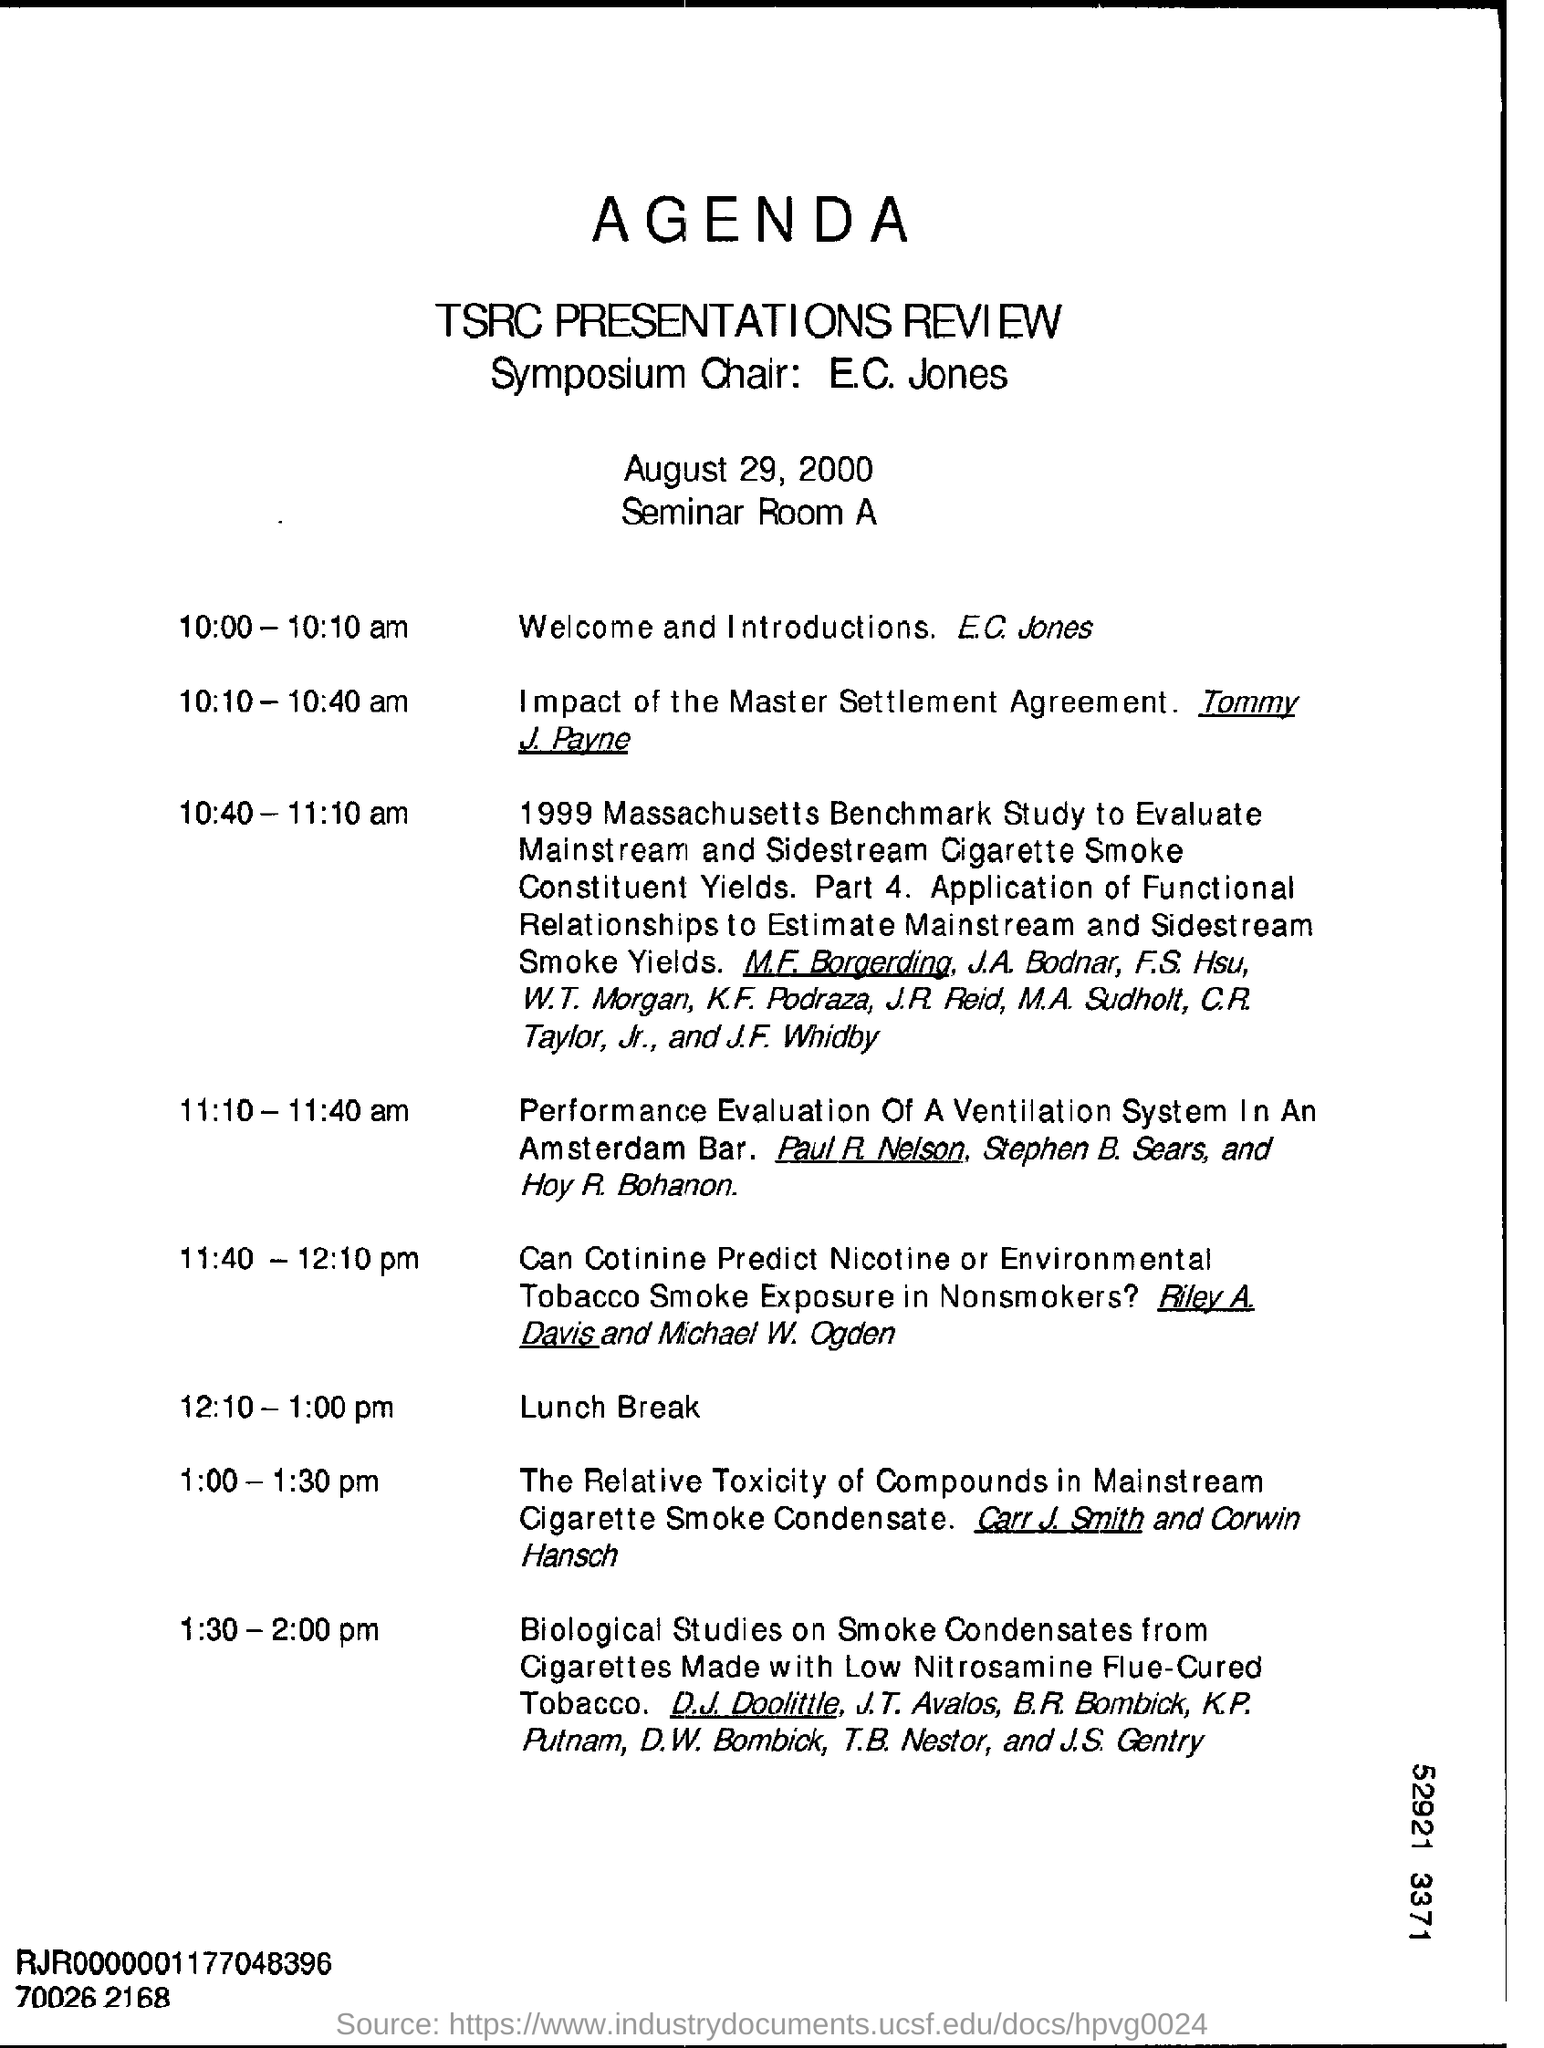Mention a couple of crucial points in this snapshot. The speaker announced that E.C. Jones would be providing the welcome and introductions. The venue of TSRC presentations review is the seminar room A. The agenda, dated August 29, 2000, will be discussed at a later time. The chairman of the symposium is E.C. Jones. 